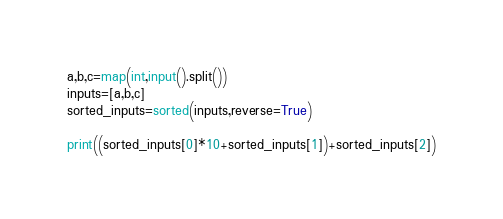<code> <loc_0><loc_0><loc_500><loc_500><_Python_>a,b,c=map(int,input().split())
inputs=[a,b,c]
sorted_inputs=sorted(inputs,reverse=True)

print((sorted_inputs[0]*10+sorted_inputs[1])+sorted_inputs[2])</code> 